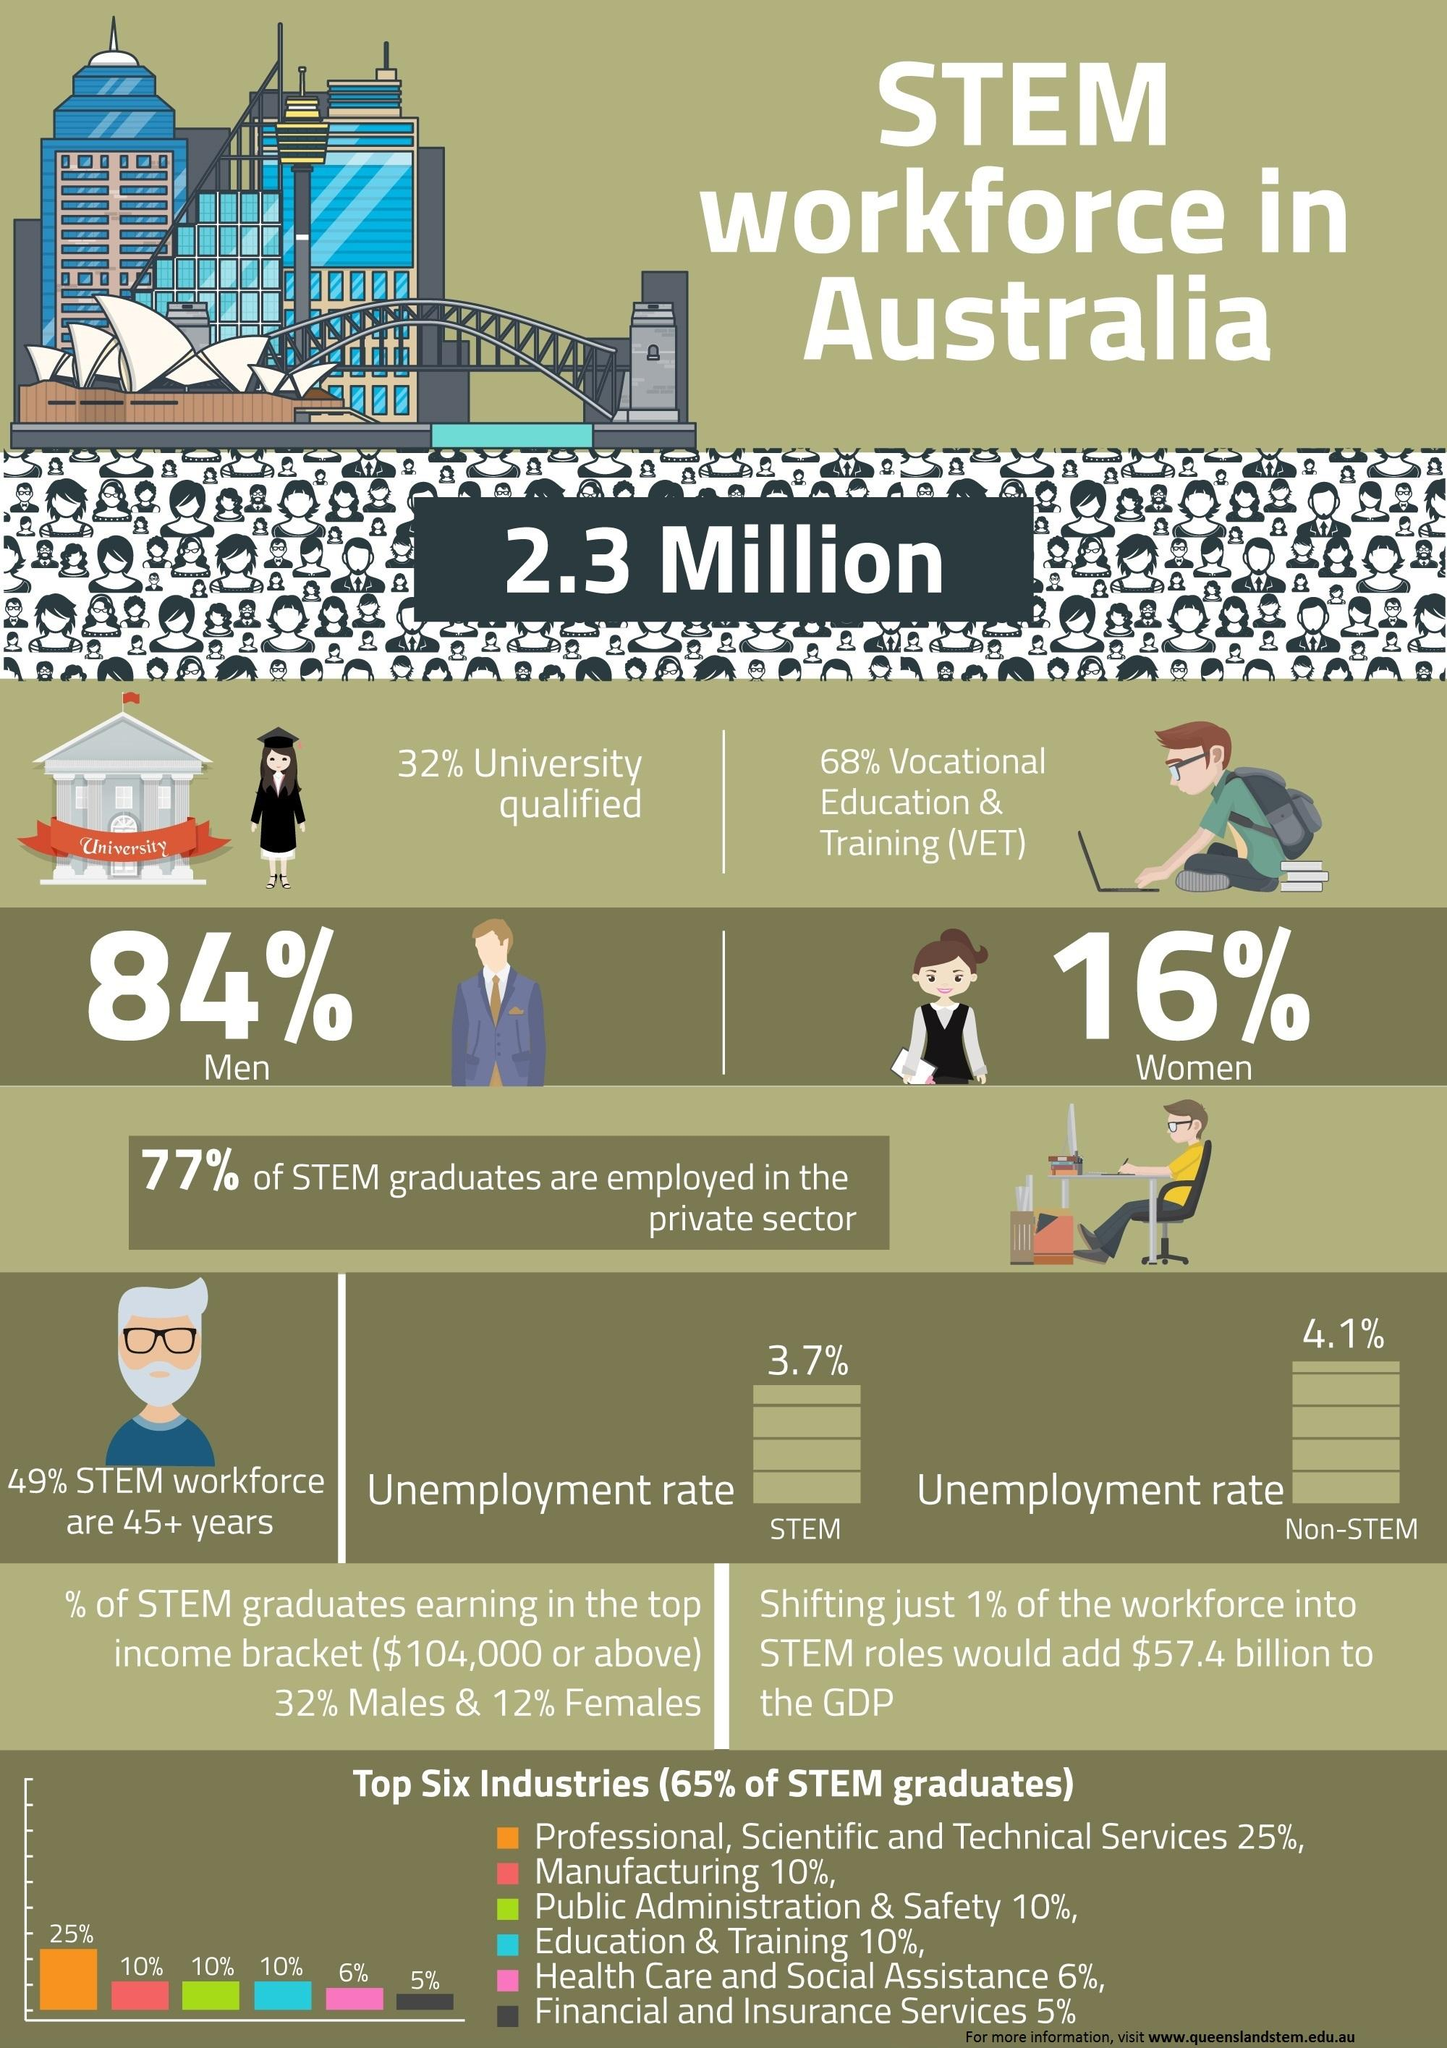Point out several critical features in this image. The unemployment rate of the STEM workforce in Australia is 3.7%. The non-STEM workforce in Australia has an unemployment rate of 4.1%. According to a recent study, it was found that 84% of the stem workforce in Australia is comprised of men. According to data, approximately 10% of STEM graduates in Australia are from the manufacturing industry. According to recent statistics, only 16% of the stem workforce in Australia is comprised of women. 